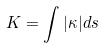<formula> <loc_0><loc_0><loc_500><loc_500>K = \int | \kappa | d s</formula> 